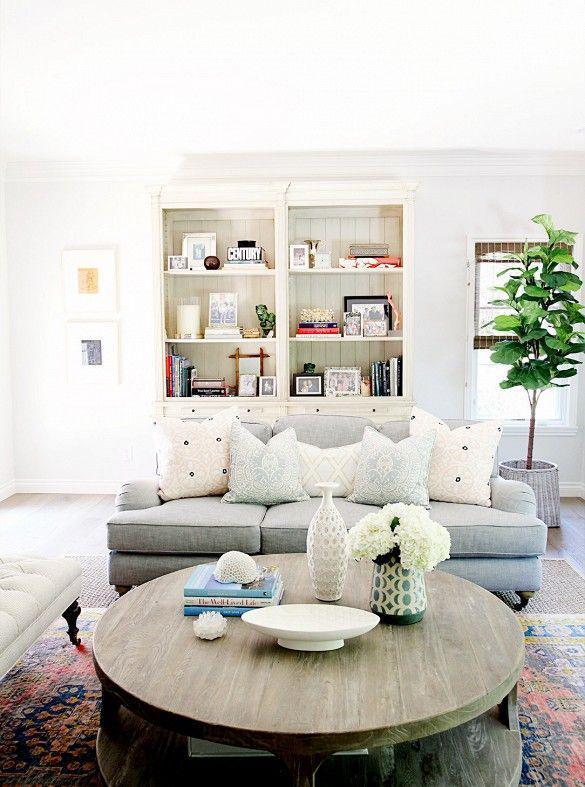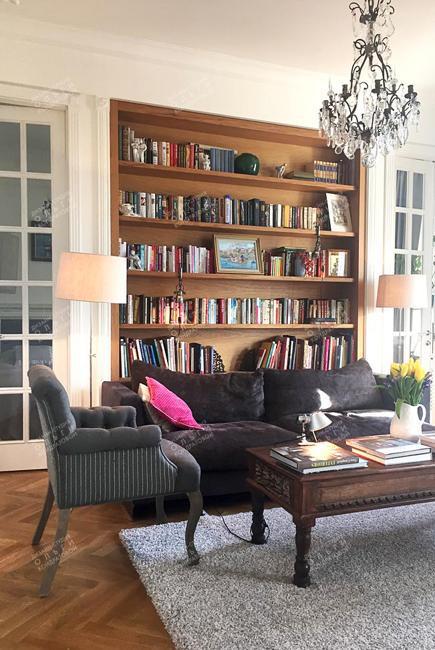The first image is the image on the left, the second image is the image on the right. Given the left and right images, does the statement "An image shows a dark sectional couch with a white pillow on one end and patterned and orange pillows on the other end." hold true? Answer yes or no. No. The first image is the image on the left, the second image is the image on the right. Given the left and right images, does the statement "In each image, a standard sized sofa with extra throw pillows and a coffee table in front of it sits parallel to a wall shelving unit." hold true? Answer yes or no. Yes. 